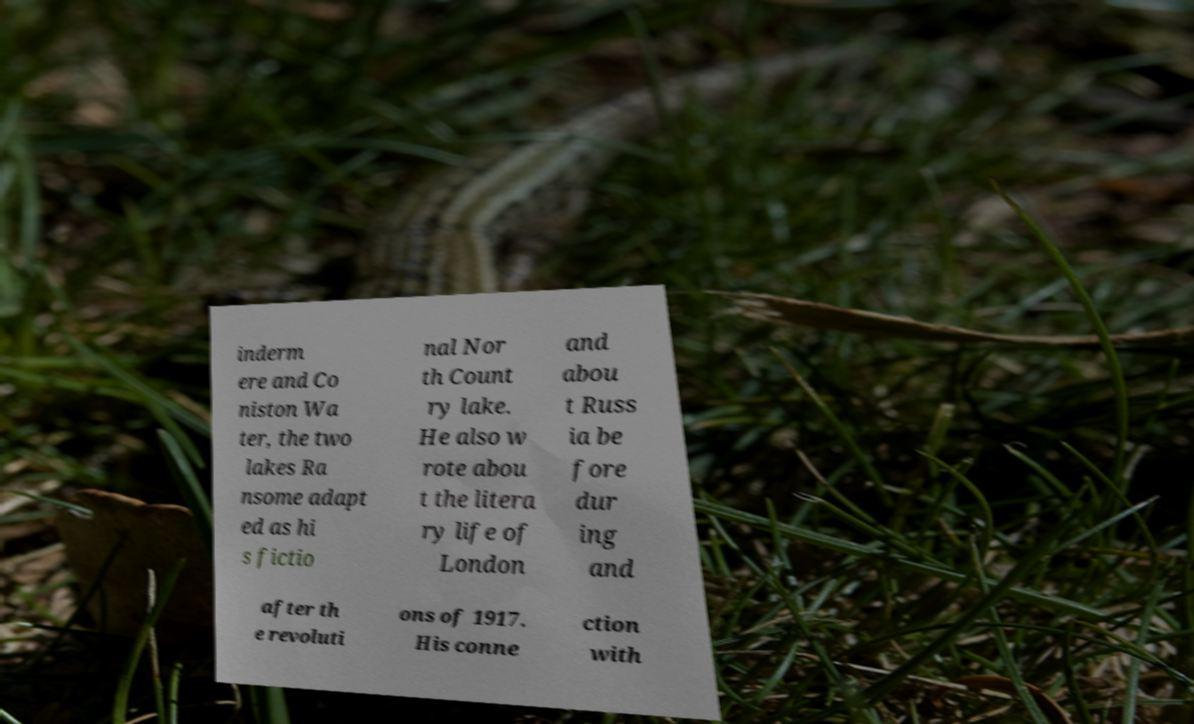What messages or text are displayed in this image? I need them in a readable, typed format. inderm ere and Co niston Wa ter, the two lakes Ra nsome adapt ed as hi s fictio nal Nor th Count ry lake. He also w rote abou t the litera ry life of London and abou t Russ ia be fore dur ing and after th e revoluti ons of 1917. His conne ction with 